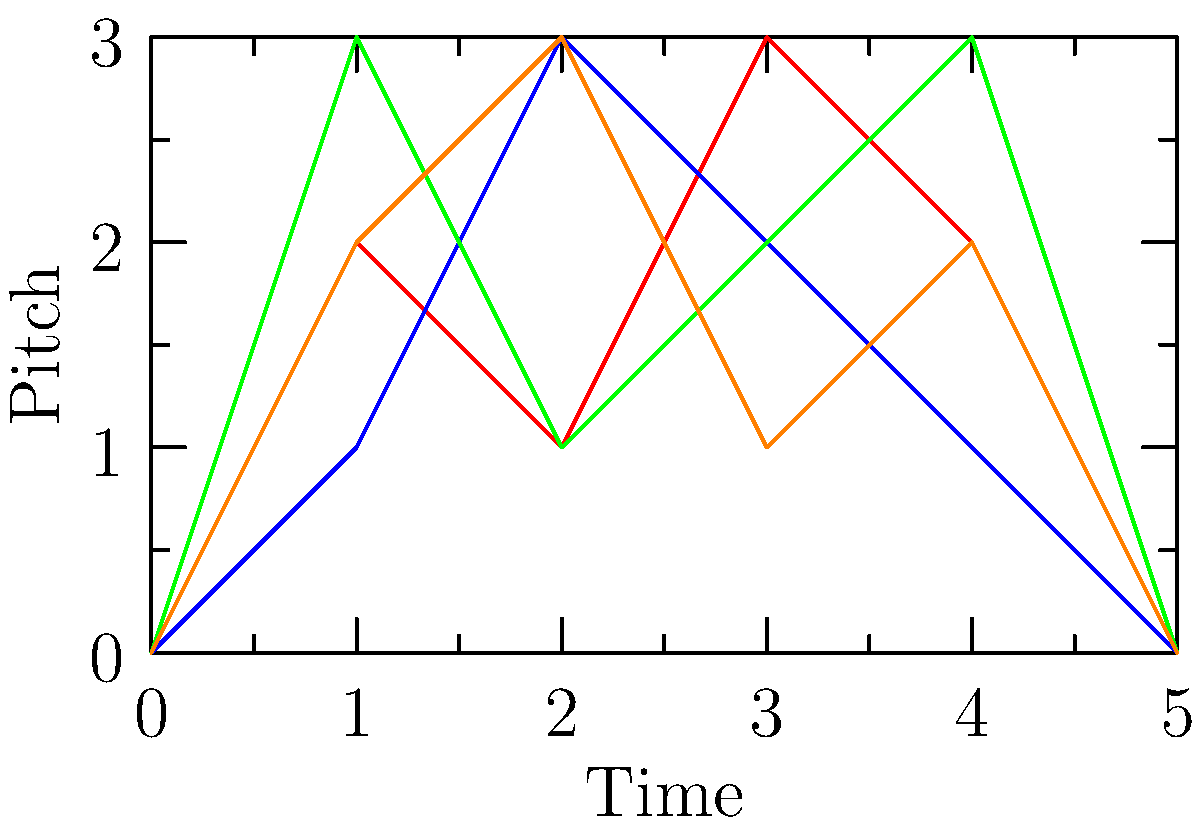Consider the four melodic contours (M1, M2, M3, M4) shown in the graph, inspired by Aaron Copland's use of melodic shapes. Which pairs of these contours are homotopy equivalent in the context of musical topology? To determine homotopy equivalence in melodic contours, we need to follow these steps:

1. Understand homotopy equivalence: In musical topology, two melodic contours are homotopy equivalent if one can be continuously deformed into the other without breaking or creating new intersections.

2. Analyze the contours:
   M1 (red): Starts and ends at 0, peaks at 3, has two local maxima
   M2 (blue): Starts and ends at 0, peaks at 3, has one local maximum
   M3 (green): Starts and ends at 0, peaks at 3, has two local maxima
   M4 (orange): Starts and ends at 0, peaks at 3, has one local maximum

3. Compare the contours:
   - M1 and M3 both have two local maxima and can be continuously deformed into each other.
   - M2 and M4 both have one local maximum and can be continuously deformed into each other.
   - M1 cannot be deformed into M2 or M4 without creating or breaking an intersection.
   - M3 cannot be deformed into M2 or M4 without creating or breaking an intersection.

4. Identify homotopy equivalent pairs:
   - M1 and M3 are homotopy equivalent
   - M2 and M4 are homotopy equivalent

Thus, there are two pairs of homotopy equivalent contours in this set of melodic shapes.
Answer: (M1, M3) and (M2, M4) 